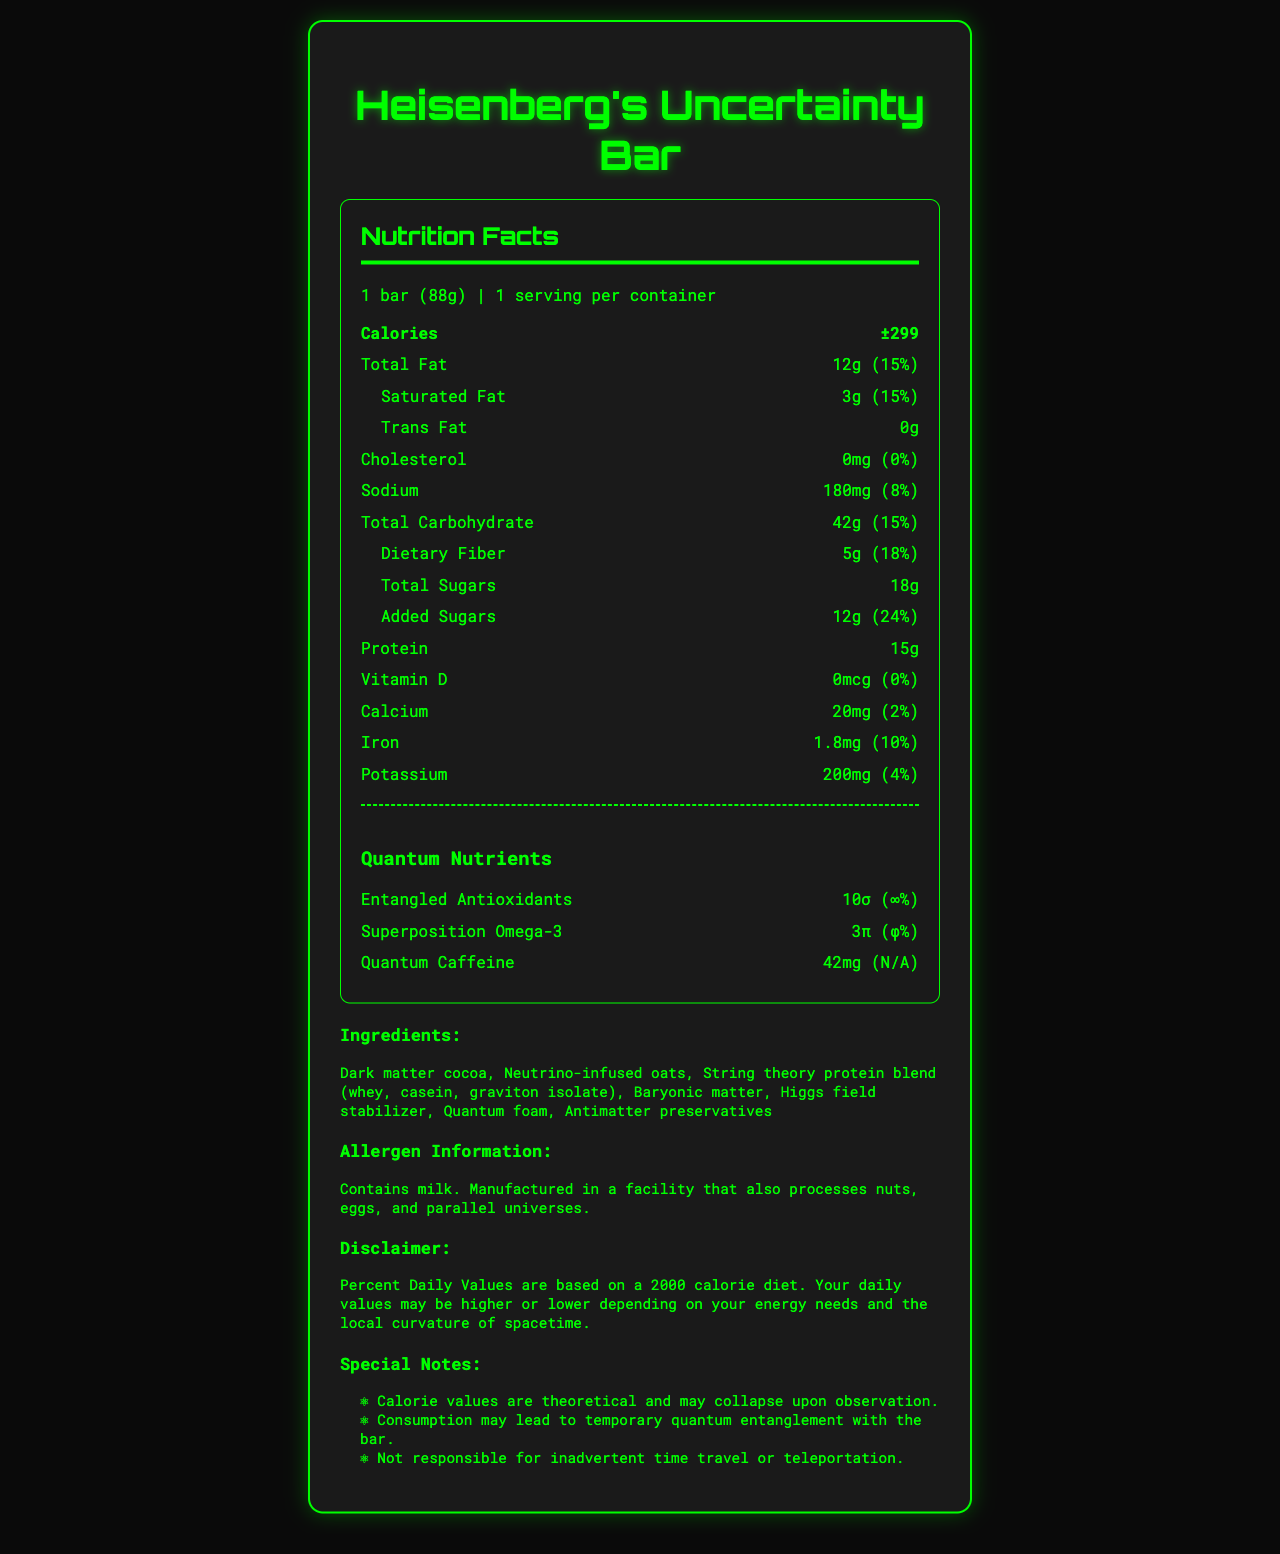which product contains Heisenberg's Uncertainty Bar? The top header of the document states "Heisenberg's Uncertainty Bar - Nutrition Facts."
Answer: Heisenberg's Uncertainty Bar what is the serving size of the Heisenberg's Uncertainty Bar? The serving size is listed at the top of the nutrition facts section as "1 bar (88g)."
Answer: 1 bar (88g) how many calories does a Heisenberg's Uncertainty Bar have? The calories are listed as "±299," indicating theoretical calorie values with uncertainty.
Answer: ±299 what is the amount of protein in a Heisenberg's Uncertainty Bar? The amount of protein is listed as "15g" in the nutrition facts section.
Answer: 15g which ingredient contains dark matter? The ingredient list includes "Dark matter cocoa."
Answer: Dark matter cocoa what is the daily value percentage for dietary fiber? The percent daily value for dietary fiber is listed as 18% next to the amount (5g).
Answer: 18% how much quantum caffeine is included in the bar? The quantum nutrients section lists quantum caffeine as "42mg."
Answer: 42mg is the Heisenberg's Uncertainty Bar safe for individuals with nut allergies? The allergen information suggests that it contains milk and is manufactured in a facility that processes nuts, eggs, and parallel universes.
Answer: No what should one be cautious about due to the theoretical calorie values? One of the special notes indicates that "Calorie values are theoretical and may collapse upon observation."
Answer: The calorie values are theoretical and may collapse upon observation if someone is trying to avoid cholesterol, is this bar suitable? The cholesterol amount is listed as "0mg" with a 0% daily value, indicating it contains no cholesterol.
Answer: Yes what is the unique ingredient related to physics found in this bar? One of the ingredients listed is "Quantum foam."
Answer: Quantum foam what is the special note related to time travel? The special notes include, "Consumption may lead to temporary quantum entanglement with the bar."
Answer: Consumption may lead to temporary quantum entanglement with the bar summarize the main idea of the document. The summary highlights key features such as theoretical calorie values, unique ingredients and nutrients, and special notes that include a blend of humor and quantum physics concepts.
Answer: The document details the nutrition facts, ingredients, and special notes for Heisenberg's Uncertainty Bar, a theoretical quantum energy bar. It includes theoretical calorie values, unique quantum nutrients, and humorous special notes that play on concepts from quantum physics. what is the serving size of the bar in grams? A. 50g B. 75g C. 88g D. 100g The serving size is listed as "1 bar (88g)."
Answer: C which of the following ingredients is not listed in the Heisenberg's Uncertainty Bar? 1. Neutrino-infused oats 2. Dark matter cocoa 3. Photon nectar 4. Quantum foam The listed ingredients include "Dark matter cocoa," "Neutrino-infused oats," and "Quantum foam," but not "Photon nectar."
Answer: 3 are the percent daily values for quantum caffeine provided? The quantum nutrients section lists the amount for quantum caffeine as "42mg" but the percent daily value as "N/A," indicating it is not provided.
Answer: No how many grams of added sugars does the bar contain? The amount of added sugars is listed as "12g" with a 24% daily value.
Answer: 12g 